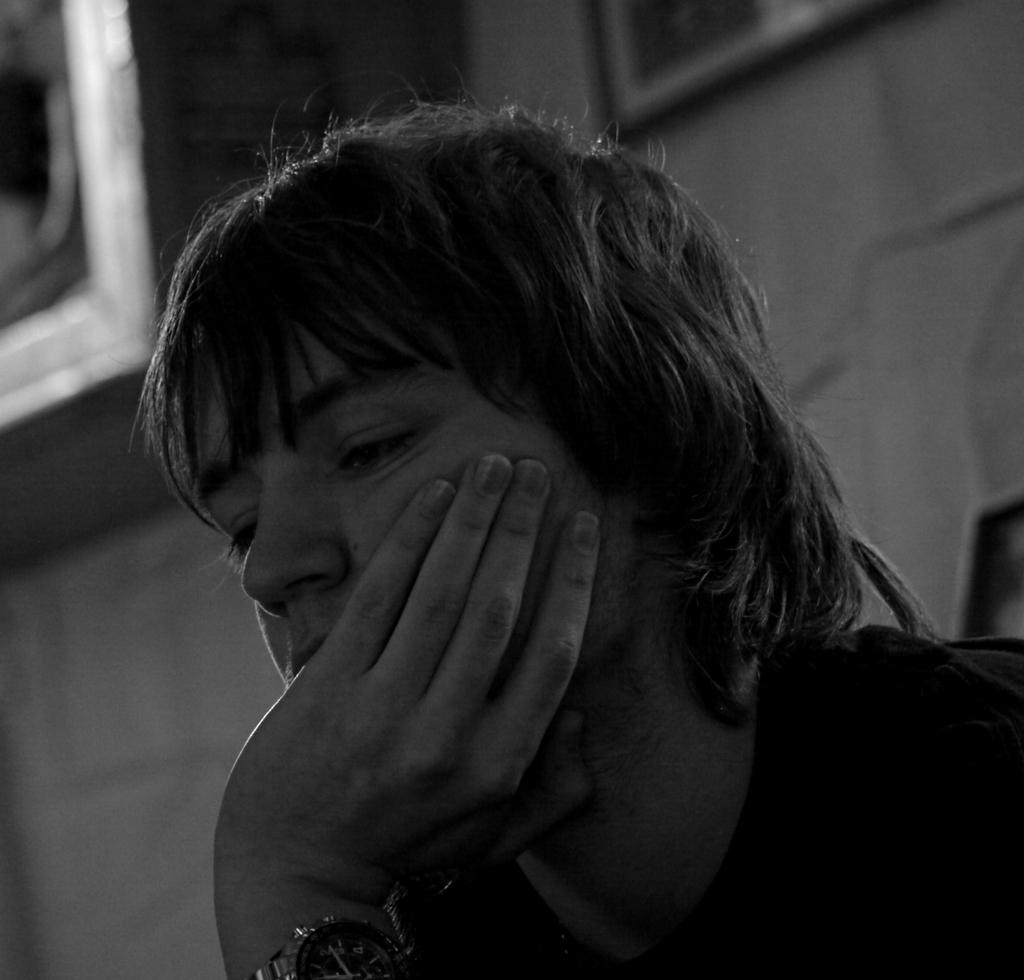What is the main subject in the foreground of the image? There is a person in the foreground of the image. What can be seen in the background of the image? There is a wall in the background of the image. What is on the wall in the image? There is a photo frame on the wall. What other object is visible in the background of the image? There is a box in the background of the image. What route does the person take to reach the battle in the image? There is no battle present in the image, and therefore no route can be determined. 